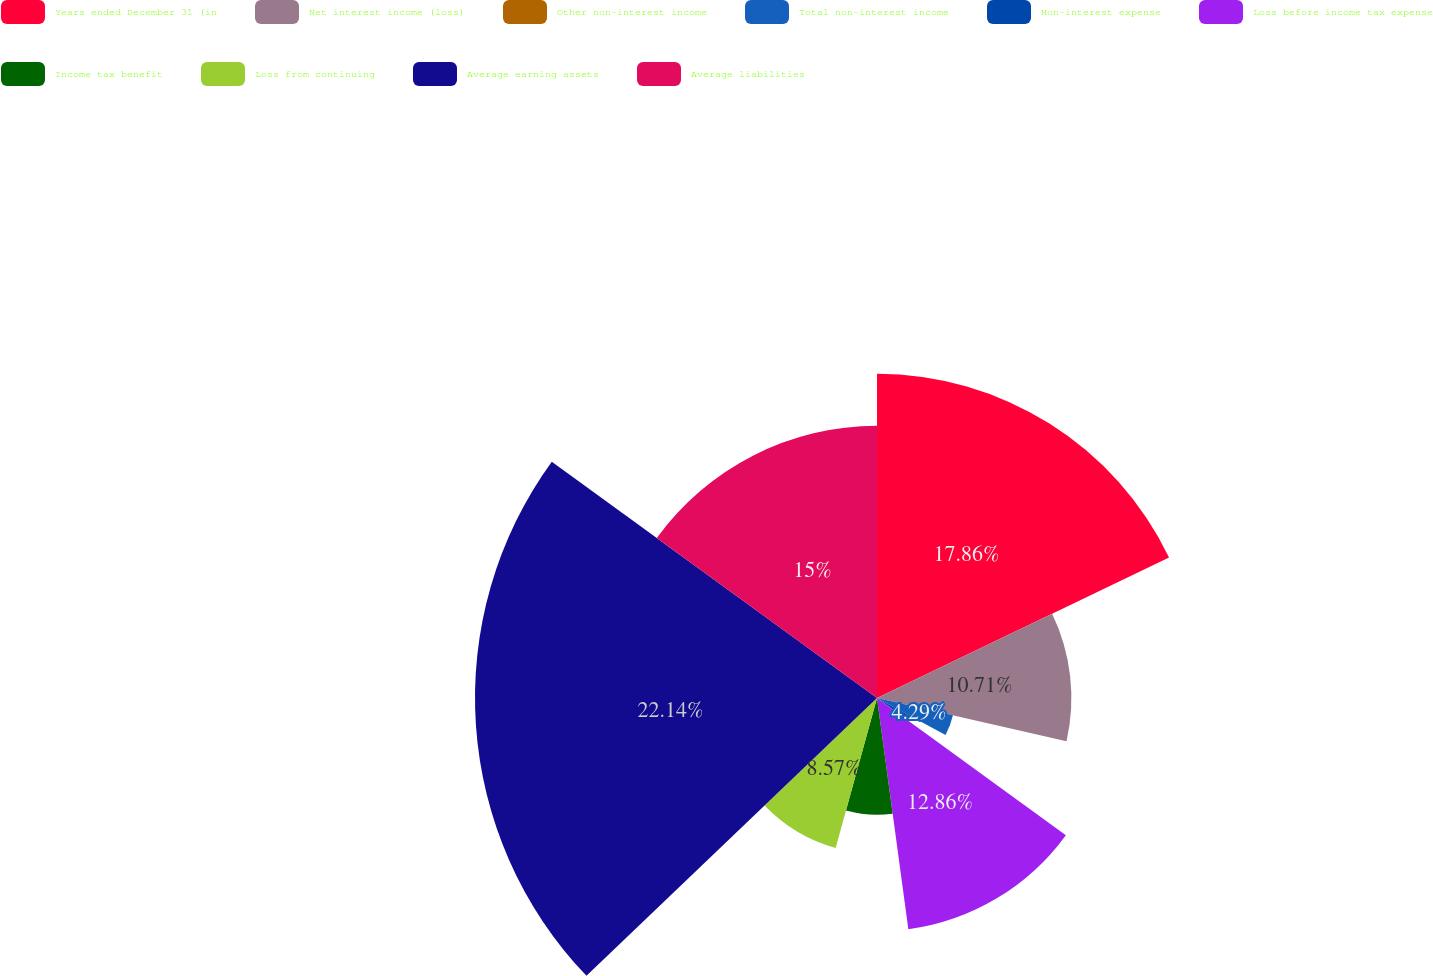Convert chart to OTSL. <chart><loc_0><loc_0><loc_500><loc_500><pie_chart><fcel>Years ended December 31 (in<fcel>Net interest income (loss)<fcel>Other non-interest income<fcel>Total non-interest income<fcel>Non-interest expense<fcel>Loss before income tax expense<fcel>Income tax benefit<fcel>Loss from continuing<fcel>Average earning assets<fcel>Average liabilities<nl><fcel>17.86%<fcel>10.71%<fcel>0.0%<fcel>4.29%<fcel>2.14%<fcel>12.86%<fcel>6.43%<fcel>8.57%<fcel>22.15%<fcel>15.0%<nl></chart> 